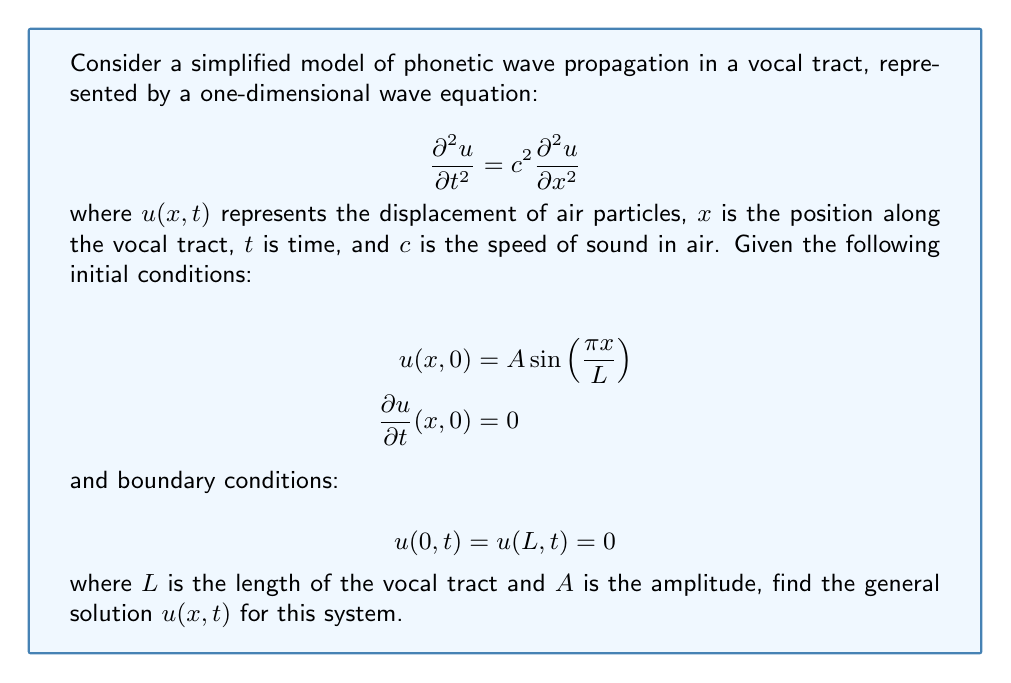Help me with this question. To solve this problem, we'll use the method of separation of variables and follow these steps:

1) Assume the solution has the form $u(x,t) = X(x)T(t)$.

2) Substitute this into the wave equation:

   $$X(x)T''(t) = c^2X''(x)T(t)$$

3) Divide both sides by $c^2X(x)T(t)$:

   $$\frac{T''(t)}{c^2T(t)} = \frac{X''(x)}{X(x)} = -k^2$$

   where $-k^2$ is a separation constant.

4) This gives us two ordinary differential equations:

   $$X''(x) + k^2X(x) = 0$$
   $$T''(t) + c^2k^2T(t) = 0$$

5) The general solutions to these equations are:

   $$X(x) = A_1\sin(kx) + B_1\cos(kx)$$
   $$T(t) = A_2\sin(ckt) + B_2\cos(ckt)$$

6) Apply the boundary conditions $u(0,t) = u(L,t) = 0$:

   $$X(0) = 0 \implies B_1 = 0$$
   $$X(L) = 0 \implies A_1\sin(kL) = 0$$

   This is satisfied when $kL = n\pi$ for $n = 1,2,3,...$

7) Therefore, the general solution is:

   $$u(x,t) = \sum_{n=1}^{\infty} [A_n\sin(\frac{n\pi x}{L})\cos(\frac{n\pi c t}{L}) + B_n\sin(\frac{n\pi x}{L})\sin(\frac{n\pi c t}{L})]$$

8) Apply the initial conditions:

   $$u(x,0) = A\sin(\frac{\pi x}{L}) = \sum_{n=1}^{\infty} A_n\sin(\frac{n\pi x}{L})$$

   This implies $A_1 = A$ and $A_n = 0$ for $n > 1$.

   $$\frac{\partial u}{\partial t}(x,0) = 0 = \sum_{n=1}^{\infty} B_n\frac{n\pi c}{L}\sin(\frac{n\pi x}{L})$$

   This implies $B_n = 0$ for all $n$.

9) Therefore, the final solution is:

   $$u(x,t) = A\sin(\frac{\pi x}{L})\cos(\frac{\pi c t}{L})$$

This solution represents a standing wave in the vocal tract, which is a simplified model of a vowel sound in phonetics.
Answer: $$u(x,t) = A\sin(\frac{\pi x}{L})\cos(\frac{\pi c t}{L})$$ 